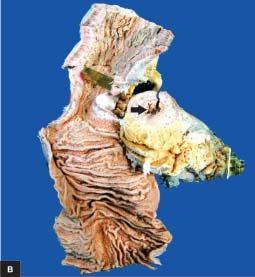where is the specimen of small intestine shown?
Answer the question using a single word or phrase. Longitudinal section along with a segment in cross section 